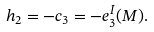<formula> <loc_0><loc_0><loc_500><loc_500>h _ { 2 } = - c _ { 3 } = - e ^ { I } _ { 3 } ( M ) .</formula> 